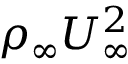Convert formula to latex. <formula><loc_0><loc_0><loc_500><loc_500>\rho _ { \infty } U _ { \infty } ^ { 2 }</formula> 